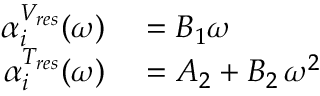<formula> <loc_0><loc_0><loc_500><loc_500>\begin{array} { r l } { \alpha _ { i } ^ { V _ { r e s } } ( \omega ) } & = B _ { 1 } \omega } \\ { \alpha _ { i } ^ { T _ { r e s } } ( \omega ) } & = A _ { 2 } + B _ { 2 } \, \omega ^ { 2 } } \end{array}</formula> 